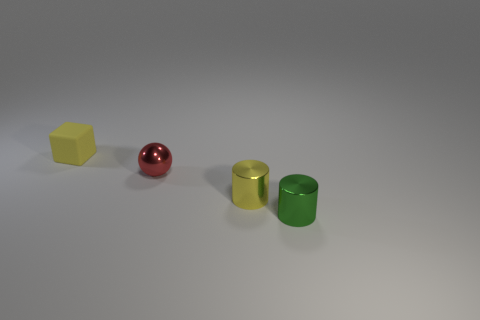Add 3 yellow cubes. How many objects exist? 7 Subtract all balls. How many objects are left? 3 Add 1 small green metallic objects. How many small green metallic objects are left? 2 Add 3 purple rubber cubes. How many purple rubber cubes exist? 3 Subtract 0 blue cylinders. How many objects are left? 4 Subtract all green shiny cylinders. Subtract all small cyan metallic objects. How many objects are left? 3 